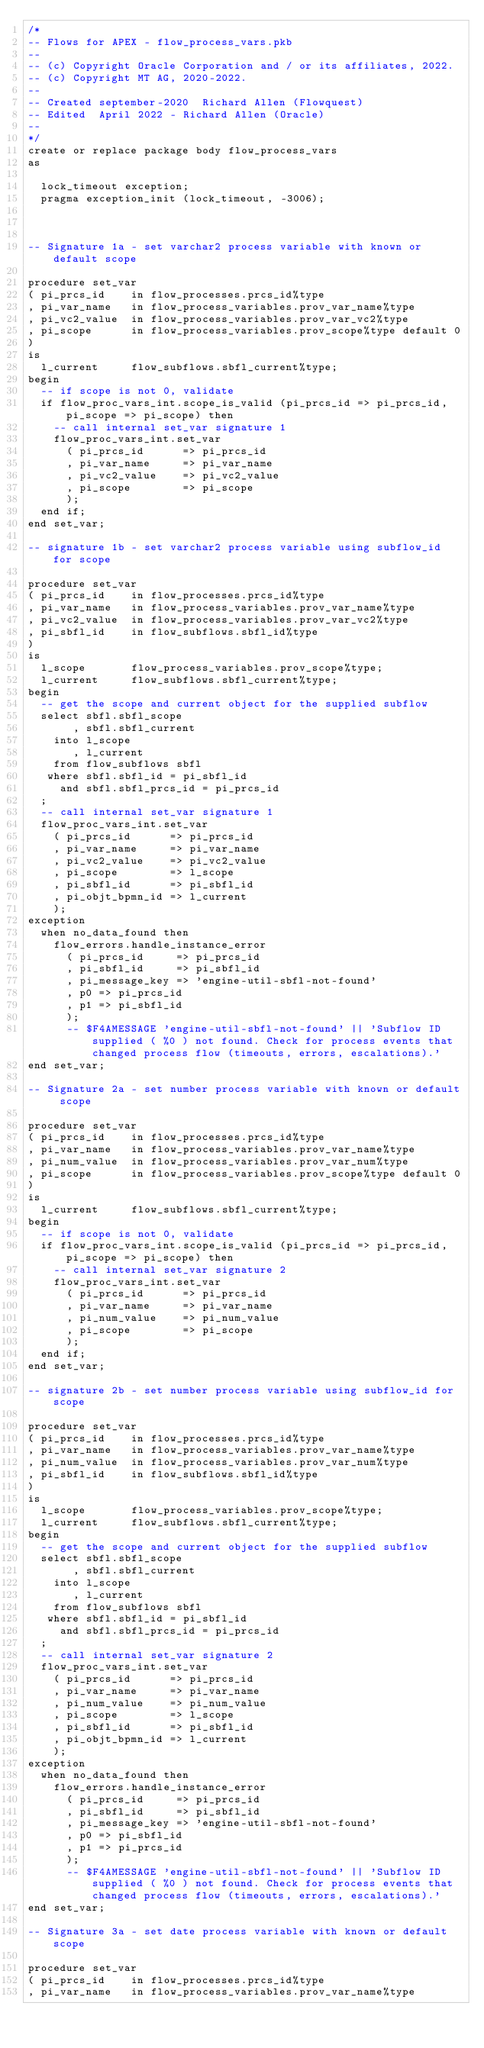<code> <loc_0><loc_0><loc_500><loc_500><_SQL_>/* 
-- Flows for APEX - flow_process_vars.pkb
-- 
-- (c) Copyright Oracle Corporation and / or its affiliates, 2022.
-- (c) Copyright MT AG, 2020-2022.
--
-- Created september-2020  Richard Allen (Flowquest) 
-- Edited  April 2022 - Richard Allen (Oracle)
--
*/
create or replace package body flow_process_vars
as

  lock_timeout exception;
  pragma exception_init (lock_timeout, -3006);



-- Signature 1a - set varchar2 process variable with known or default scope

procedure set_var
( pi_prcs_id    in flow_processes.prcs_id%type
, pi_var_name   in flow_process_variables.prov_var_name%type
, pi_vc2_value  in flow_process_variables.prov_var_vc2%type
, pi_scope      in flow_process_variables.prov_scope%type default 0
)
is 
  l_current     flow_subflows.sbfl_current%type;
begin
  -- if scope is not 0, validate
  if flow_proc_vars_int.scope_is_valid (pi_prcs_id => pi_prcs_id, pi_scope => pi_scope) then
    -- call internal set_var signature 1
    flow_proc_vars_int.set_var
      ( pi_prcs_id      => pi_prcs_id
      , pi_var_name     => pi_var_name
      , pi_vc2_value    => pi_vc2_value
      , pi_scope        => pi_scope
      );
  end if;
end set_var;

-- signature 1b - set varchar2 process variable using subflow_id for scope

procedure set_var
( pi_prcs_id    in flow_processes.prcs_id%type
, pi_var_name   in flow_process_variables.prov_var_name%type
, pi_vc2_value  in flow_process_variables.prov_var_vc2%type
, pi_sbfl_id    in flow_subflows.sbfl_id%type 
)
is 
  l_scope       flow_process_variables.prov_scope%type;
  l_current     flow_subflows.sbfl_current%type;
begin
  -- get the scope and current object for the supplied subflow
  select sbfl.sbfl_scope
       , sbfl.sbfl_current
    into l_scope
       , l_current
    from flow_subflows sbfl
   where sbfl.sbfl_id = pi_sbfl_id
     and sbfl.sbfl_prcs_id = pi_prcs_id
  ;
  -- call internal set_var signature 1
  flow_proc_vars_int.set_var
    ( pi_prcs_id      => pi_prcs_id
    , pi_var_name     => pi_var_name
    , pi_vc2_value    => pi_vc2_value
    , pi_scope        => l_scope
    , pi_sbfl_id      => pi_sbfl_id
    , pi_objt_bpmn_id => l_current
    );
exception
  when no_data_found then
    flow_errors.handle_instance_error
      ( pi_prcs_id     => pi_prcs_id
      , pi_sbfl_id     => pi_sbfl_id
      , pi_message_key => 'engine-util-sbfl-not-found'
      , p0 => pi_prcs_id
      , p1 => pi_sbfl_id
      );
      -- $F4AMESSAGE 'engine-util-sbfl-not-found' || 'Subflow ID supplied ( %0 ) not found. Check for process events that changed process flow (timeouts, errors, escalations).'  
end set_var;

-- Signature 2a - set number process variable with known or default scope

procedure set_var
( pi_prcs_id    in flow_processes.prcs_id%type
, pi_var_name   in flow_process_variables.prov_var_name%type
, pi_num_value  in flow_process_variables.prov_var_num%type
, pi_scope      in flow_process_variables.prov_scope%type default 0
)
is 
  l_current     flow_subflows.sbfl_current%type;
begin
  -- if scope is not 0, validate
  if flow_proc_vars_int.scope_is_valid (pi_prcs_id => pi_prcs_id, pi_scope => pi_scope) then
    -- call internal set_var signature 2
    flow_proc_vars_int.set_var
      ( pi_prcs_id      => pi_prcs_id
      , pi_var_name     => pi_var_name
      , pi_num_value    => pi_num_value
      , pi_scope        => pi_scope
      );
  end if;
end set_var;

-- signature 2b - set number process variable using subflow_id for scope

procedure set_var
( pi_prcs_id    in flow_processes.prcs_id%type
, pi_var_name   in flow_process_variables.prov_var_name%type
, pi_num_value  in flow_process_variables.prov_var_num%type
, pi_sbfl_id    in flow_subflows.sbfl_id%type 
)
is 
  l_scope       flow_process_variables.prov_scope%type;
  l_current     flow_subflows.sbfl_current%type;
begin
  -- get the scope and current object for the supplied subflow
  select sbfl.sbfl_scope
       , sbfl.sbfl_current
    into l_scope
       , l_current
    from flow_subflows sbfl
   where sbfl.sbfl_id = pi_sbfl_id
     and sbfl.sbfl_prcs_id = pi_prcs_id
  ;
  -- call internal set_var signature 2
  flow_proc_vars_int.set_var
    ( pi_prcs_id      => pi_prcs_id
    , pi_var_name     => pi_var_name
    , pi_num_value    => pi_num_value
    , pi_scope        => l_scope
    , pi_sbfl_id      => pi_sbfl_id
    , pi_objt_bpmn_id => l_current
    );
exception
  when no_data_found then
    flow_errors.handle_instance_error
      ( pi_prcs_id     => pi_prcs_id
      , pi_sbfl_id     => pi_sbfl_id
      , pi_message_key => 'engine-util-sbfl-not-found'
      , p0 => pi_sbfl_id
      , p1 => pi_prcs_id
      );
      -- $F4AMESSAGE 'engine-util-sbfl-not-found' || 'Subflow ID supplied ( %0 ) not found. Check for process events that changed process flow (timeouts, errors, escalations).'  
end set_var;

-- Signature 3a - set date process variable with known or default scope

procedure set_var
( pi_prcs_id    in flow_processes.prcs_id%type
, pi_var_name   in flow_process_variables.prov_var_name%type</code> 